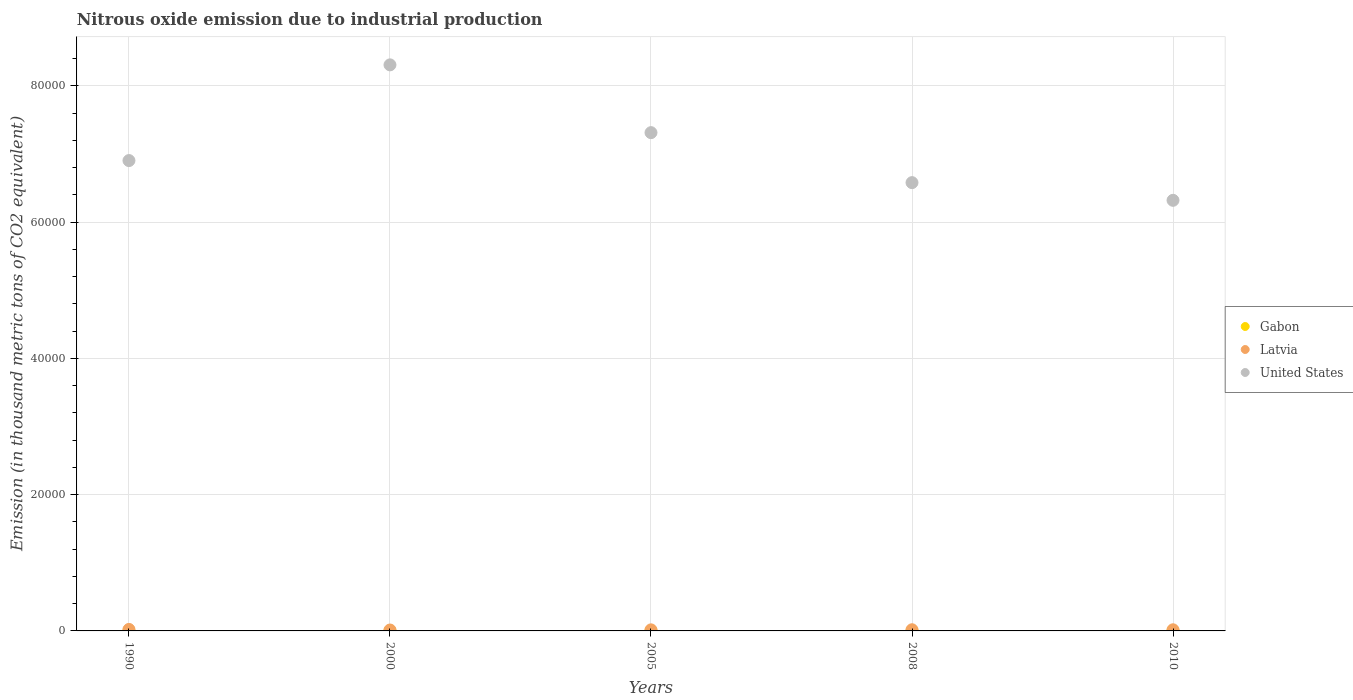How many different coloured dotlines are there?
Give a very brief answer. 3. Is the number of dotlines equal to the number of legend labels?
Offer a very short reply. Yes. What is the amount of nitrous oxide emitted in United States in 2005?
Ensure brevity in your answer.  7.31e+04. Across all years, what is the maximum amount of nitrous oxide emitted in Latvia?
Your answer should be compact. 220. Across all years, what is the minimum amount of nitrous oxide emitted in United States?
Give a very brief answer. 6.32e+04. In which year was the amount of nitrous oxide emitted in Gabon minimum?
Your response must be concise. 1990. What is the total amount of nitrous oxide emitted in United States in the graph?
Provide a short and direct response. 3.54e+05. What is the difference between the amount of nitrous oxide emitted in United States in 2008 and that in 2010?
Keep it short and to the point. 2596.6. What is the difference between the amount of nitrous oxide emitted in Latvia in 2005 and the amount of nitrous oxide emitted in United States in 2000?
Give a very brief answer. -8.29e+04. What is the average amount of nitrous oxide emitted in Gabon per year?
Make the answer very short. 40.98. In the year 2000, what is the difference between the amount of nitrous oxide emitted in Gabon and amount of nitrous oxide emitted in Latvia?
Provide a short and direct response. -87.9. In how many years, is the amount of nitrous oxide emitted in United States greater than 56000 thousand metric tons?
Offer a terse response. 5. What is the ratio of the amount of nitrous oxide emitted in Latvia in 2000 to that in 2005?
Keep it short and to the point. 0.85. Is the amount of nitrous oxide emitted in United States in 2000 less than that in 2005?
Your answer should be very brief. No. Is the difference between the amount of nitrous oxide emitted in Gabon in 2000 and 2010 greater than the difference between the amount of nitrous oxide emitted in Latvia in 2000 and 2010?
Offer a terse response. Yes. What is the difference between the highest and the second highest amount of nitrous oxide emitted in United States?
Provide a succinct answer. 9949.1. What is the difference between the highest and the lowest amount of nitrous oxide emitted in Gabon?
Provide a succinct answer. 22. Is the sum of the amount of nitrous oxide emitted in Gabon in 2000 and 2008 greater than the maximum amount of nitrous oxide emitted in United States across all years?
Keep it short and to the point. No. Is it the case that in every year, the sum of the amount of nitrous oxide emitted in Latvia and amount of nitrous oxide emitted in Gabon  is greater than the amount of nitrous oxide emitted in United States?
Your answer should be compact. No. Does the amount of nitrous oxide emitted in Gabon monotonically increase over the years?
Keep it short and to the point. No. Is the amount of nitrous oxide emitted in United States strictly greater than the amount of nitrous oxide emitted in Latvia over the years?
Ensure brevity in your answer.  Yes. Are the values on the major ticks of Y-axis written in scientific E-notation?
Your response must be concise. No. Does the graph contain any zero values?
Ensure brevity in your answer.  No. How many legend labels are there?
Make the answer very short. 3. How are the legend labels stacked?
Ensure brevity in your answer.  Vertical. What is the title of the graph?
Provide a succinct answer. Nitrous oxide emission due to industrial production. Does "Burkina Faso" appear as one of the legend labels in the graph?
Keep it short and to the point. No. What is the label or title of the Y-axis?
Keep it short and to the point. Emission (in thousand metric tons of CO2 equivalent). What is the Emission (in thousand metric tons of CO2 equivalent) in Gabon in 1990?
Provide a short and direct response. 26.7. What is the Emission (in thousand metric tons of CO2 equivalent) of Latvia in 1990?
Keep it short and to the point. 220. What is the Emission (in thousand metric tons of CO2 equivalent) of United States in 1990?
Ensure brevity in your answer.  6.90e+04. What is the Emission (in thousand metric tons of CO2 equivalent) of Gabon in 2000?
Offer a terse response. 45.8. What is the Emission (in thousand metric tons of CO2 equivalent) in Latvia in 2000?
Give a very brief answer. 133.7. What is the Emission (in thousand metric tons of CO2 equivalent) in United States in 2000?
Your answer should be very brief. 8.31e+04. What is the Emission (in thousand metric tons of CO2 equivalent) of Gabon in 2005?
Your answer should be very brief. 48.7. What is the Emission (in thousand metric tons of CO2 equivalent) in Latvia in 2005?
Make the answer very short. 157.3. What is the Emission (in thousand metric tons of CO2 equivalent) in United States in 2005?
Your answer should be very brief. 7.31e+04. What is the Emission (in thousand metric tons of CO2 equivalent) of Gabon in 2008?
Your answer should be compact. 40.1. What is the Emission (in thousand metric tons of CO2 equivalent) of Latvia in 2008?
Provide a short and direct response. 172.1. What is the Emission (in thousand metric tons of CO2 equivalent) in United States in 2008?
Provide a succinct answer. 6.58e+04. What is the Emission (in thousand metric tons of CO2 equivalent) of Gabon in 2010?
Offer a terse response. 43.6. What is the Emission (in thousand metric tons of CO2 equivalent) in Latvia in 2010?
Give a very brief answer. 166.3. What is the Emission (in thousand metric tons of CO2 equivalent) of United States in 2010?
Your answer should be very brief. 6.32e+04. Across all years, what is the maximum Emission (in thousand metric tons of CO2 equivalent) in Gabon?
Keep it short and to the point. 48.7. Across all years, what is the maximum Emission (in thousand metric tons of CO2 equivalent) of Latvia?
Give a very brief answer. 220. Across all years, what is the maximum Emission (in thousand metric tons of CO2 equivalent) in United States?
Ensure brevity in your answer.  8.31e+04. Across all years, what is the minimum Emission (in thousand metric tons of CO2 equivalent) of Gabon?
Your response must be concise. 26.7. Across all years, what is the minimum Emission (in thousand metric tons of CO2 equivalent) of Latvia?
Provide a succinct answer. 133.7. Across all years, what is the minimum Emission (in thousand metric tons of CO2 equivalent) in United States?
Your response must be concise. 6.32e+04. What is the total Emission (in thousand metric tons of CO2 equivalent) in Gabon in the graph?
Provide a succinct answer. 204.9. What is the total Emission (in thousand metric tons of CO2 equivalent) in Latvia in the graph?
Offer a very short reply. 849.4. What is the total Emission (in thousand metric tons of CO2 equivalent) in United States in the graph?
Keep it short and to the point. 3.54e+05. What is the difference between the Emission (in thousand metric tons of CO2 equivalent) of Gabon in 1990 and that in 2000?
Provide a short and direct response. -19.1. What is the difference between the Emission (in thousand metric tons of CO2 equivalent) of Latvia in 1990 and that in 2000?
Provide a succinct answer. 86.3. What is the difference between the Emission (in thousand metric tons of CO2 equivalent) of United States in 1990 and that in 2000?
Offer a very short reply. -1.40e+04. What is the difference between the Emission (in thousand metric tons of CO2 equivalent) of Gabon in 1990 and that in 2005?
Your answer should be very brief. -22. What is the difference between the Emission (in thousand metric tons of CO2 equivalent) of Latvia in 1990 and that in 2005?
Keep it short and to the point. 62.7. What is the difference between the Emission (in thousand metric tons of CO2 equivalent) of United States in 1990 and that in 2005?
Your answer should be compact. -4098.5. What is the difference between the Emission (in thousand metric tons of CO2 equivalent) of Gabon in 1990 and that in 2008?
Provide a succinct answer. -13.4. What is the difference between the Emission (in thousand metric tons of CO2 equivalent) of Latvia in 1990 and that in 2008?
Make the answer very short. 47.9. What is the difference between the Emission (in thousand metric tons of CO2 equivalent) in United States in 1990 and that in 2008?
Provide a succinct answer. 3238.6. What is the difference between the Emission (in thousand metric tons of CO2 equivalent) of Gabon in 1990 and that in 2010?
Ensure brevity in your answer.  -16.9. What is the difference between the Emission (in thousand metric tons of CO2 equivalent) of Latvia in 1990 and that in 2010?
Provide a short and direct response. 53.7. What is the difference between the Emission (in thousand metric tons of CO2 equivalent) of United States in 1990 and that in 2010?
Your answer should be very brief. 5835.2. What is the difference between the Emission (in thousand metric tons of CO2 equivalent) in Gabon in 2000 and that in 2005?
Your answer should be compact. -2.9. What is the difference between the Emission (in thousand metric tons of CO2 equivalent) in Latvia in 2000 and that in 2005?
Ensure brevity in your answer.  -23.6. What is the difference between the Emission (in thousand metric tons of CO2 equivalent) of United States in 2000 and that in 2005?
Make the answer very short. 9949.1. What is the difference between the Emission (in thousand metric tons of CO2 equivalent) in Latvia in 2000 and that in 2008?
Your answer should be compact. -38.4. What is the difference between the Emission (in thousand metric tons of CO2 equivalent) in United States in 2000 and that in 2008?
Provide a succinct answer. 1.73e+04. What is the difference between the Emission (in thousand metric tons of CO2 equivalent) of Latvia in 2000 and that in 2010?
Ensure brevity in your answer.  -32.6. What is the difference between the Emission (in thousand metric tons of CO2 equivalent) of United States in 2000 and that in 2010?
Keep it short and to the point. 1.99e+04. What is the difference between the Emission (in thousand metric tons of CO2 equivalent) in Gabon in 2005 and that in 2008?
Your answer should be compact. 8.6. What is the difference between the Emission (in thousand metric tons of CO2 equivalent) in Latvia in 2005 and that in 2008?
Keep it short and to the point. -14.8. What is the difference between the Emission (in thousand metric tons of CO2 equivalent) of United States in 2005 and that in 2008?
Ensure brevity in your answer.  7337.1. What is the difference between the Emission (in thousand metric tons of CO2 equivalent) in Gabon in 2005 and that in 2010?
Provide a succinct answer. 5.1. What is the difference between the Emission (in thousand metric tons of CO2 equivalent) in Latvia in 2005 and that in 2010?
Your response must be concise. -9. What is the difference between the Emission (in thousand metric tons of CO2 equivalent) of United States in 2005 and that in 2010?
Keep it short and to the point. 9933.7. What is the difference between the Emission (in thousand metric tons of CO2 equivalent) in United States in 2008 and that in 2010?
Make the answer very short. 2596.6. What is the difference between the Emission (in thousand metric tons of CO2 equivalent) in Gabon in 1990 and the Emission (in thousand metric tons of CO2 equivalent) in Latvia in 2000?
Your answer should be compact. -107. What is the difference between the Emission (in thousand metric tons of CO2 equivalent) of Gabon in 1990 and the Emission (in thousand metric tons of CO2 equivalent) of United States in 2000?
Provide a succinct answer. -8.31e+04. What is the difference between the Emission (in thousand metric tons of CO2 equivalent) of Latvia in 1990 and the Emission (in thousand metric tons of CO2 equivalent) of United States in 2000?
Keep it short and to the point. -8.29e+04. What is the difference between the Emission (in thousand metric tons of CO2 equivalent) of Gabon in 1990 and the Emission (in thousand metric tons of CO2 equivalent) of Latvia in 2005?
Provide a succinct answer. -130.6. What is the difference between the Emission (in thousand metric tons of CO2 equivalent) of Gabon in 1990 and the Emission (in thousand metric tons of CO2 equivalent) of United States in 2005?
Offer a very short reply. -7.31e+04. What is the difference between the Emission (in thousand metric tons of CO2 equivalent) of Latvia in 1990 and the Emission (in thousand metric tons of CO2 equivalent) of United States in 2005?
Keep it short and to the point. -7.29e+04. What is the difference between the Emission (in thousand metric tons of CO2 equivalent) in Gabon in 1990 and the Emission (in thousand metric tons of CO2 equivalent) in Latvia in 2008?
Provide a short and direct response. -145.4. What is the difference between the Emission (in thousand metric tons of CO2 equivalent) in Gabon in 1990 and the Emission (in thousand metric tons of CO2 equivalent) in United States in 2008?
Keep it short and to the point. -6.58e+04. What is the difference between the Emission (in thousand metric tons of CO2 equivalent) of Latvia in 1990 and the Emission (in thousand metric tons of CO2 equivalent) of United States in 2008?
Give a very brief answer. -6.56e+04. What is the difference between the Emission (in thousand metric tons of CO2 equivalent) of Gabon in 1990 and the Emission (in thousand metric tons of CO2 equivalent) of Latvia in 2010?
Offer a terse response. -139.6. What is the difference between the Emission (in thousand metric tons of CO2 equivalent) in Gabon in 1990 and the Emission (in thousand metric tons of CO2 equivalent) in United States in 2010?
Ensure brevity in your answer.  -6.32e+04. What is the difference between the Emission (in thousand metric tons of CO2 equivalent) in Latvia in 1990 and the Emission (in thousand metric tons of CO2 equivalent) in United States in 2010?
Ensure brevity in your answer.  -6.30e+04. What is the difference between the Emission (in thousand metric tons of CO2 equivalent) in Gabon in 2000 and the Emission (in thousand metric tons of CO2 equivalent) in Latvia in 2005?
Give a very brief answer. -111.5. What is the difference between the Emission (in thousand metric tons of CO2 equivalent) of Gabon in 2000 and the Emission (in thousand metric tons of CO2 equivalent) of United States in 2005?
Make the answer very short. -7.31e+04. What is the difference between the Emission (in thousand metric tons of CO2 equivalent) of Latvia in 2000 and the Emission (in thousand metric tons of CO2 equivalent) of United States in 2005?
Keep it short and to the point. -7.30e+04. What is the difference between the Emission (in thousand metric tons of CO2 equivalent) in Gabon in 2000 and the Emission (in thousand metric tons of CO2 equivalent) in Latvia in 2008?
Keep it short and to the point. -126.3. What is the difference between the Emission (in thousand metric tons of CO2 equivalent) of Gabon in 2000 and the Emission (in thousand metric tons of CO2 equivalent) of United States in 2008?
Give a very brief answer. -6.58e+04. What is the difference between the Emission (in thousand metric tons of CO2 equivalent) of Latvia in 2000 and the Emission (in thousand metric tons of CO2 equivalent) of United States in 2008?
Keep it short and to the point. -6.57e+04. What is the difference between the Emission (in thousand metric tons of CO2 equivalent) in Gabon in 2000 and the Emission (in thousand metric tons of CO2 equivalent) in Latvia in 2010?
Give a very brief answer. -120.5. What is the difference between the Emission (in thousand metric tons of CO2 equivalent) in Gabon in 2000 and the Emission (in thousand metric tons of CO2 equivalent) in United States in 2010?
Provide a short and direct response. -6.32e+04. What is the difference between the Emission (in thousand metric tons of CO2 equivalent) in Latvia in 2000 and the Emission (in thousand metric tons of CO2 equivalent) in United States in 2010?
Ensure brevity in your answer.  -6.31e+04. What is the difference between the Emission (in thousand metric tons of CO2 equivalent) of Gabon in 2005 and the Emission (in thousand metric tons of CO2 equivalent) of Latvia in 2008?
Offer a very short reply. -123.4. What is the difference between the Emission (in thousand metric tons of CO2 equivalent) of Gabon in 2005 and the Emission (in thousand metric tons of CO2 equivalent) of United States in 2008?
Your response must be concise. -6.58e+04. What is the difference between the Emission (in thousand metric tons of CO2 equivalent) in Latvia in 2005 and the Emission (in thousand metric tons of CO2 equivalent) in United States in 2008?
Keep it short and to the point. -6.56e+04. What is the difference between the Emission (in thousand metric tons of CO2 equivalent) in Gabon in 2005 and the Emission (in thousand metric tons of CO2 equivalent) in Latvia in 2010?
Offer a very short reply. -117.6. What is the difference between the Emission (in thousand metric tons of CO2 equivalent) of Gabon in 2005 and the Emission (in thousand metric tons of CO2 equivalent) of United States in 2010?
Give a very brief answer. -6.32e+04. What is the difference between the Emission (in thousand metric tons of CO2 equivalent) in Latvia in 2005 and the Emission (in thousand metric tons of CO2 equivalent) in United States in 2010?
Make the answer very short. -6.31e+04. What is the difference between the Emission (in thousand metric tons of CO2 equivalent) of Gabon in 2008 and the Emission (in thousand metric tons of CO2 equivalent) of Latvia in 2010?
Your response must be concise. -126.2. What is the difference between the Emission (in thousand metric tons of CO2 equivalent) in Gabon in 2008 and the Emission (in thousand metric tons of CO2 equivalent) in United States in 2010?
Your response must be concise. -6.32e+04. What is the difference between the Emission (in thousand metric tons of CO2 equivalent) in Latvia in 2008 and the Emission (in thousand metric tons of CO2 equivalent) in United States in 2010?
Provide a short and direct response. -6.30e+04. What is the average Emission (in thousand metric tons of CO2 equivalent) of Gabon per year?
Ensure brevity in your answer.  40.98. What is the average Emission (in thousand metric tons of CO2 equivalent) in Latvia per year?
Offer a very short reply. 169.88. What is the average Emission (in thousand metric tons of CO2 equivalent) of United States per year?
Your response must be concise. 7.09e+04. In the year 1990, what is the difference between the Emission (in thousand metric tons of CO2 equivalent) in Gabon and Emission (in thousand metric tons of CO2 equivalent) in Latvia?
Your answer should be compact. -193.3. In the year 1990, what is the difference between the Emission (in thousand metric tons of CO2 equivalent) of Gabon and Emission (in thousand metric tons of CO2 equivalent) of United States?
Offer a terse response. -6.90e+04. In the year 1990, what is the difference between the Emission (in thousand metric tons of CO2 equivalent) in Latvia and Emission (in thousand metric tons of CO2 equivalent) in United States?
Ensure brevity in your answer.  -6.88e+04. In the year 2000, what is the difference between the Emission (in thousand metric tons of CO2 equivalent) in Gabon and Emission (in thousand metric tons of CO2 equivalent) in Latvia?
Your answer should be compact. -87.9. In the year 2000, what is the difference between the Emission (in thousand metric tons of CO2 equivalent) in Gabon and Emission (in thousand metric tons of CO2 equivalent) in United States?
Ensure brevity in your answer.  -8.30e+04. In the year 2000, what is the difference between the Emission (in thousand metric tons of CO2 equivalent) in Latvia and Emission (in thousand metric tons of CO2 equivalent) in United States?
Your answer should be very brief. -8.30e+04. In the year 2005, what is the difference between the Emission (in thousand metric tons of CO2 equivalent) in Gabon and Emission (in thousand metric tons of CO2 equivalent) in Latvia?
Make the answer very short. -108.6. In the year 2005, what is the difference between the Emission (in thousand metric tons of CO2 equivalent) of Gabon and Emission (in thousand metric tons of CO2 equivalent) of United States?
Keep it short and to the point. -7.31e+04. In the year 2005, what is the difference between the Emission (in thousand metric tons of CO2 equivalent) of Latvia and Emission (in thousand metric tons of CO2 equivalent) of United States?
Keep it short and to the point. -7.30e+04. In the year 2008, what is the difference between the Emission (in thousand metric tons of CO2 equivalent) in Gabon and Emission (in thousand metric tons of CO2 equivalent) in Latvia?
Your answer should be compact. -132. In the year 2008, what is the difference between the Emission (in thousand metric tons of CO2 equivalent) of Gabon and Emission (in thousand metric tons of CO2 equivalent) of United States?
Your answer should be very brief. -6.58e+04. In the year 2008, what is the difference between the Emission (in thousand metric tons of CO2 equivalent) in Latvia and Emission (in thousand metric tons of CO2 equivalent) in United States?
Give a very brief answer. -6.56e+04. In the year 2010, what is the difference between the Emission (in thousand metric tons of CO2 equivalent) in Gabon and Emission (in thousand metric tons of CO2 equivalent) in Latvia?
Provide a short and direct response. -122.7. In the year 2010, what is the difference between the Emission (in thousand metric tons of CO2 equivalent) of Gabon and Emission (in thousand metric tons of CO2 equivalent) of United States?
Keep it short and to the point. -6.32e+04. In the year 2010, what is the difference between the Emission (in thousand metric tons of CO2 equivalent) in Latvia and Emission (in thousand metric tons of CO2 equivalent) in United States?
Provide a succinct answer. -6.30e+04. What is the ratio of the Emission (in thousand metric tons of CO2 equivalent) in Gabon in 1990 to that in 2000?
Give a very brief answer. 0.58. What is the ratio of the Emission (in thousand metric tons of CO2 equivalent) of Latvia in 1990 to that in 2000?
Provide a short and direct response. 1.65. What is the ratio of the Emission (in thousand metric tons of CO2 equivalent) in United States in 1990 to that in 2000?
Your response must be concise. 0.83. What is the ratio of the Emission (in thousand metric tons of CO2 equivalent) of Gabon in 1990 to that in 2005?
Make the answer very short. 0.55. What is the ratio of the Emission (in thousand metric tons of CO2 equivalent) in Latvia in 1990 to that in 2005?
Ensure brevity in your answer.  1.4. What is the ratio of the Emission (in thousand metric tons of CO2 equivalent) of United States in 1990 to that in 2005?
Provide a short and direct response. 0.94. What is the ratio of the Emission (in thousand metric tons of CO2 equivalent) of Gabon in 1990 to that in 2008?
Make the answer very short. 0.67. What is the ratio of the Emission (in thousand metric tons of CO2 equivalent) of Latvia in 1990 to that in 2008?
Offer a terse response. 1.28. What is the ratio of the Emission (in thousand metric tons of CO2 equivalent) in United States in 1990 to that in 2008?
Keep it short and to the point. 1.05. What is the ratio of the Emission (in thousand metric tons of CO2 equivalent) of Gabon in 1990 to that in 2010?
Provide a short and direct response. 0.61. What is the ratio of the Emission (in thousand metric tons of CO2 equivalent) in Latvia in 1990 to that in 2010?
Provide a succinct answer. 1.32. What is the ratio of the Emission (in thousand metric tons of CO2 equivalent) in United States in 1990 to that in 2010?
Provide a succinct answer. 1.09. What is the ratio of the Emission (in thousand metric tons of CO2 equivalent) of Gabon in 2000 to that in 2005?
Your answer should be very brief. 0.94. What is the ratio of the Emission (in thousand metric tons of CO2 equivalent) in Latvia in 2000 to that in 2005?
Your response must be concise. 0.85. What is the ratio of the Emission (in thousand metric tons of CO2 equivalent) of United States in 2000 to that in 2005?
Make the answer very short. 1.14. What is the ratio of the Emission (in thousand metric tons of CO2 equivalent) of Gabon in 2000 to that in 2008?
Ensure brevity in your answer.  1.14. What is the ratio of the Emission (in thousand metric tons of CO2 equivalent) in Latvia in 2000 to that in 2008?
Make the answer very short. 0.78. What is the ratio of the Emission (in thousand metric tons of CO2 equivalent) in United States in 2000 to that in 2008?
Provide a succinct answer. 1.26. What is the ratio of the Emission (in thousand metric tons of CO2 equivalent) of Gabon in 2000 to that in 2010?
Offer a terse response. 1.05. What is the ratio of the Emission (in thousand metric tons of CO2 equivalent) in Latvia in 2000 to that in 2010?
Your answer should be very brief. 0.8. What is the ratio of the Emission (in thousand metric tons of CO2 equivalent) of United States in 2000 to that in 2010?
Provide a succinct answer. 1.31. What is the ratio of the Emission (in thousand metric tons of CO2 equivalent) of Gabon in 2005 to that in 2008?
Your answer should be compact. 1.21. What is the ratio of the Emission (in thousand metric tons of CO2 equivalent) of Latvia in 2005 to that in 2008?
Make the answer very short. 0.91. What is the ratio of the Emission (in thousand metric tons of CO2 equivalent) in United States in 2005 to that in 2008?
Offer a very short reply. 1.11. What is the ratio of the Emission (in thousand metric tons of CO2 equivalent) of Gabon in 2005 to that in 2010?
Your response must be concise. 1.12. What is the ratio of the Emission (in thousand metric tons of CO2 equivalent) in Latvia in 2005 to that in 2010?
Give a very brief answer. 0.95. What is the ratio of the Emission (in thousand metric tons of CO2 equivalent) in United States in 2005 to that in 2010?
Provide a succinct answer. 1.16. What is the ratio of the Emission (in thousand metric tons of CO2 equivalent) in Gabon in 2008 to that in 2010?
Offer a terse response. 0.92. What is the ratio of the Emission (in thousand metric tons of CO2 equivalent) in Latvia in 2008 to that in 2010?
Make the answer very short. 1.03. What is the ratio of the Emission (in thousand metric tons of CO2 equivalent) in United States in 2008 to that in 2010?
Offer a very short reply. 1.04. What is the difference between the highest and the second highest Emission (in thousand metric tons of CO2 equivalent) in Latvia?
Offer a terse response. 47.9. What is the difference between the highest and the second highest Emission (in thousand metric tons of CO2 equivalent) in United States?
Provide a succinct answer. 9949.1. What is the difference between the highest and the lowest Emission (in thousand metric tons of CO2 equivalent) of Gabon?
Your response must be concise. 22. What is the difference between the highest and the lowest Emission (in thousand metric tons of CO2 equivalent) in Latvia?
Your response must be concise. 86.3. What is the difference between the highest and the lowest Emission (in thousand metric tons of CO2 equivalent) of United States?
Give a very brief answer. 1.99e+04. 